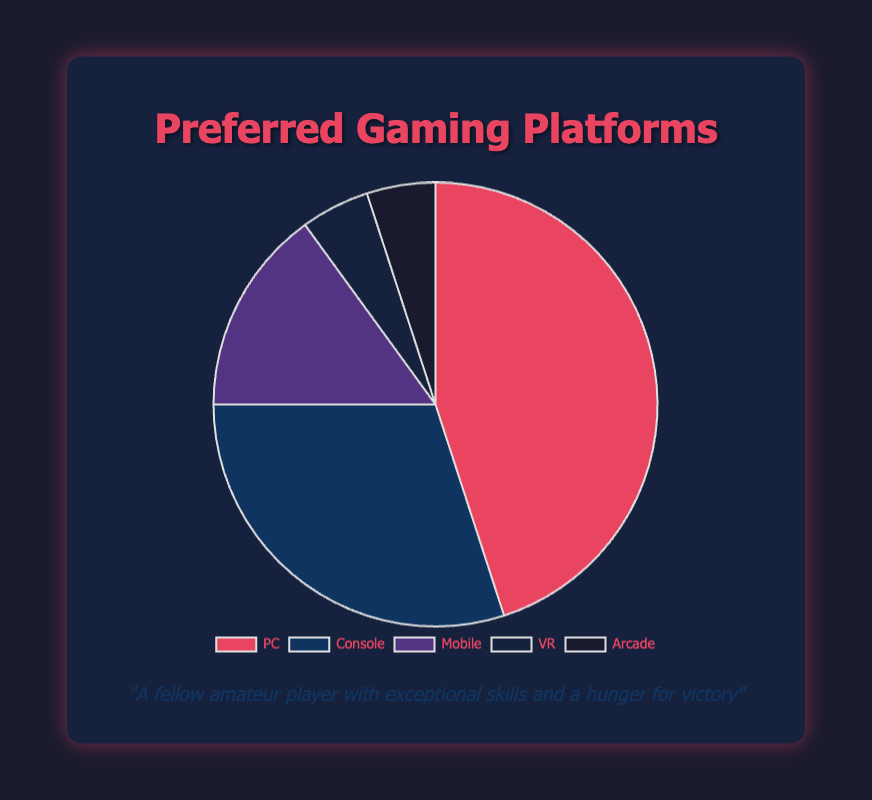What is the most preferred gaming platform? The pie chart shows gaming platforms with their corresponding percentages. The largest portion is for PC, denoted by 45%, making it the most preferred gaming platform.
Answer: PC Which gaming platform is preferred by the least percentage of people? By examining the pie chart, the smallest portions represent VR and Arcade, both at 5%. Any of these platforms is the least preferred.
Answer: VR and Arcade What is the combined percentage of preferences for PC and Console? Add the percentages for PC and Console. PC is 45% and Console is 30%, so 45% + 30% = 75%.
Answer: 75% How does the preference for Mobile compare to VR in terms of percentage? Mobile has a preference of 15% while VR has 5%. 15% is three times larger than 5%.
Answer: Mobile's preference is three times larger than VR's What percentage of players prefer platforms other than PC and Console? Sum the percentages of Mobile, VR, and Arcade. They are 15%, 5%, and 5% respectively. Thus, 15% + 5% + 5% = 25%.
Answer: 25% Which platform has the second highest preference? The pie chart shows that PC has the highest preference at 45%. The next highest percentage is Console at 30%.
Answer: Console What is the difference in preference percentage between Console and Mobile? Subtract the percentage for Mobile from the percentage for Console. Console is 30% and Mobile is 15%, so 30% - 15% = 15%.
Answer: 15% What does the red portion of the chart represent? The red portion of the chart represents the largest segment, which is PC, preferred by 45% of the people.
Answer: PC Which platform has the same percentage of preference as VR? From the pie chart, both VR and Arcade have a preference of 5%.
Answer: Arcade If we combine VR and Arcade preferences, what will be their total percentage compared to Mobile's preference? Add the preferences of VR and Arcade: 5% + 5% = 10%. Mobile's preference is 15%. Thus, VR and Arcade combined (10%) are less preferred than Mobile (15%).
Answer: 10% vs 15% What is the visual color representation for Mobile's segment on the pie chart? Assessing the pie chart, Mobile's segment is represented by a purple color.
Answer: Purple 